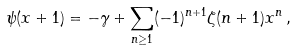<formula> <loc_0><loc_0><loc_500><loc_500>\psi ( x + 1 ) = - \gamma + \sum _ { n \geq 1 } ( - 1 ) ^ { n + 1 } \zeta ( n + 1 ) x ^ { n } \, ,</formula> 